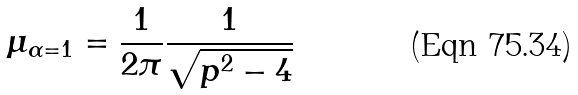<formula> <loc_0><loc_0><loc_500><loc_500>\mu _ { \alpha = 1 } = \frac { 1 } { 2 \pi } \frac { 1 } { \sqrt { p ^ { 2 } - 4 } }</formula> 